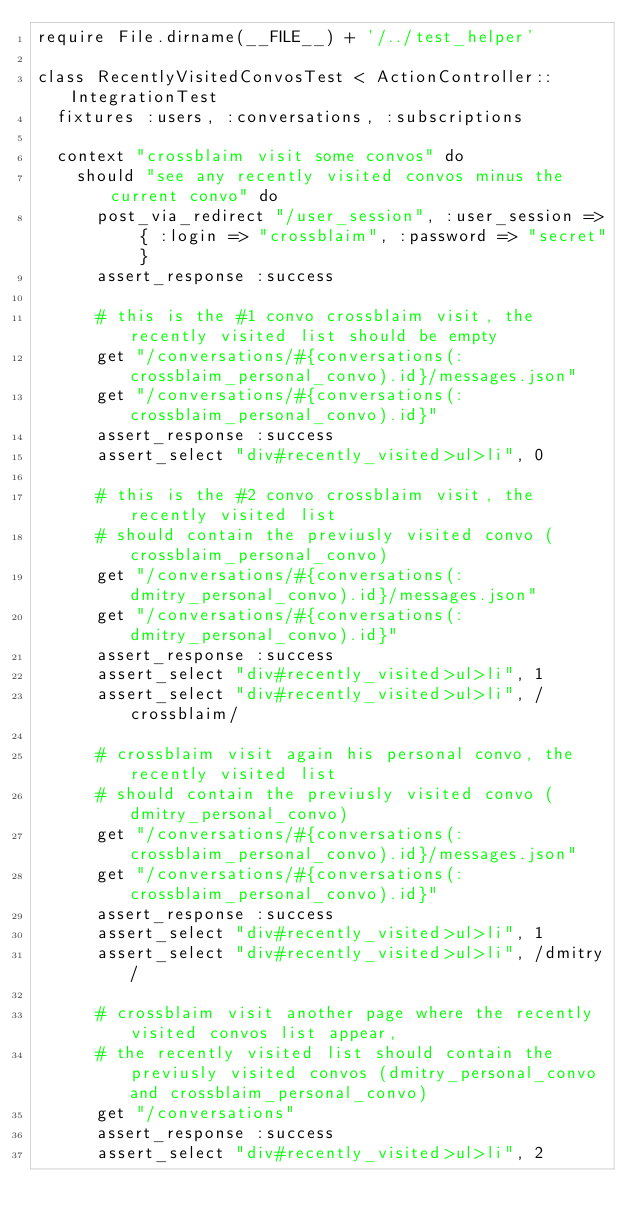Convert code to text. <code><loc_0><loc_0><loc_500><loc_500><_Ruby_>require File.dirname(__FILE__) + '/../test_helper'

class RecentlyVisitedConvosTest < ActionController::IntegrationTest
  fixtures :users, :conversations, :subscriptions

  context "crossblaim visit some convos" do
    should "see any recently visited convos minus the current convo" do
      post_via_redirect "/user_session", :user_session => { :login => "crossblaim", :password => "secret" }
      assert_response :success
      
      # this is the #1 convo crossblaim visit, the recently visited list should be empty 
      get "/conversations/#{conversations(:crossblaim_personal_convo).id}/messages.json"
      get "/conversations/#{conversations(:crossblaim_personal_convo).id}"
      assert_response :success
      assert_select "div#recently_visited>ul>li", 0
      
      # this is the #2 convo crossblaim visit, the recently visited list
      # should contain the previusly visited convo (crossblaim_personal_convo)
      get "/conversations/#{conversations(:dmitry_personal_convo).id}/messages.json"
      get "/conversations/#{conversations(:dmitry_personal_convo).id}"
      assert_response :success
      assert_select "div#recently_visited>ul>li", 1
      assert_select "div#recently_visited>ul>li", /crossblaim/
      
      # crossblaim visit again his personal convo, the recently visited list
      # should contain the previusly visited convo (dmitry_personal_convo)
      get "/conversations/#{conversations(:crossblaim_personal_convo).id}/messages.json"
      get "/conversations/#{conversations(:crossblaim_personal_convo).id}"
      assert_response :success
      assert_select "div#recently_visited>ul>li", 1
      assert_select "div#recently_visited>ul>li", /dmitry/
      
      # crossblaim visit another page where the recently visited convos list appear,
      # the recently visited list should contain the previusly visited convos (dmitry_personal_convo and crossblaim_personal_convo)
      get "/conversations"
      assert_response :success
      assert_select "div#recently_visited>ul>li", 2</code> 